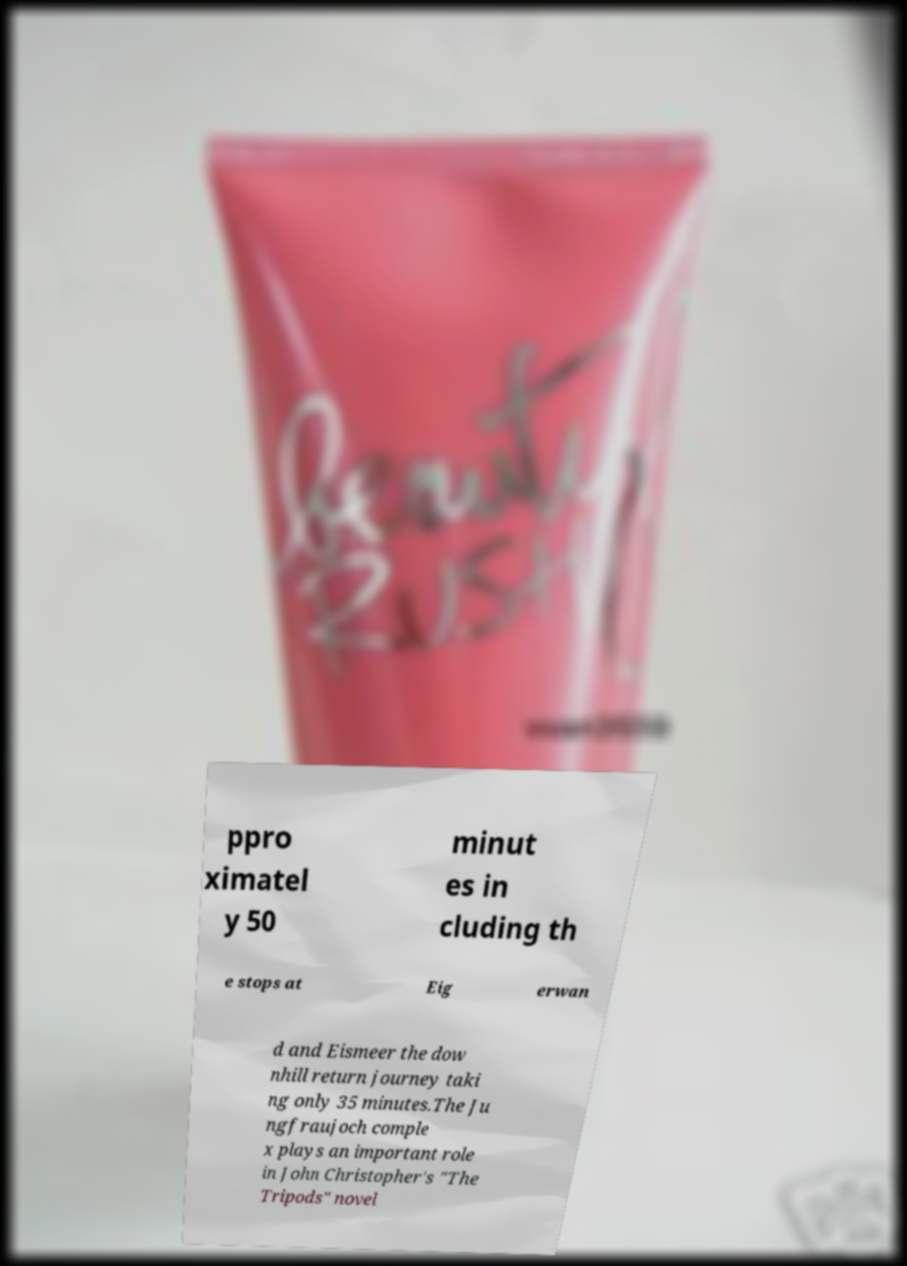Could you assist in decoding the text presented in this image and type it out clearly? ppro ximatel y 50 minut es in cluding th e stops at Eig erwan d and Eismeer the dow nhill return journey taki ng only 35 minutes.The Ju ngfraujoch comple x plays an important role in John Christopher's "The Tripods" novel 